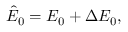Convert formula to latex. <formula><loc_0><loc_0><loc_500><loc_500>\hat { E } _ { 0 } = E _ { 0 } + \Delta E _ { 0 } ,</formula> 